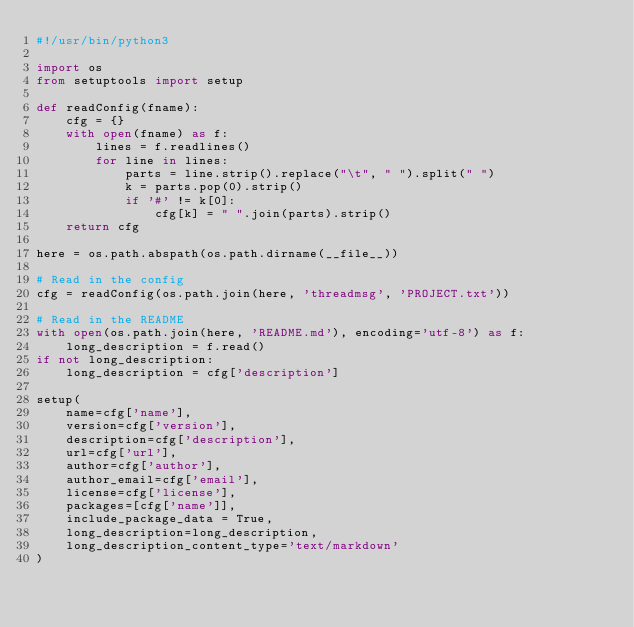<code> <loc_0><loc_0><loc_500><loc_500><_Python_>#!/usr/bin/python3

import os
from setuptools import setup

def readConfig(fname):
    cfg = {}
    with open(fname) as f:
        lines = f.readlines()
        for line in lines:
            parts = line.strip().replace("\t", " ").split(" ")
            k = parts.pop(0).strip()
            if '#' != k[0]:
                cfg[k] = " ".join(parts).strip()
    return cfg

here = os.path.abspath(os.path.dirname(__file__))

# Read in the config
cfg = readConfig(os.path.join(here, 'threadmsg', 'PROJECT.txt'))

# Read in the README
with open(os.path.join(here, 'README.md'), encoding='utf-8') as f:
    long_description = f.read()
if not long_description:
    long_description = cfg['description']

setup(
    name=cfg['name'],
    version=cfg['version'],
    description=cfg['description'],
    url=cfg['url'],
    author=cfg['author'],
    author_email=cfg['email'],
    license=cfg['license'],
    packages=[cfg['name']],
    include_package_data = True,
    long_description=long_description,
    long_description_content_type='text/markdown'
)
</code> 